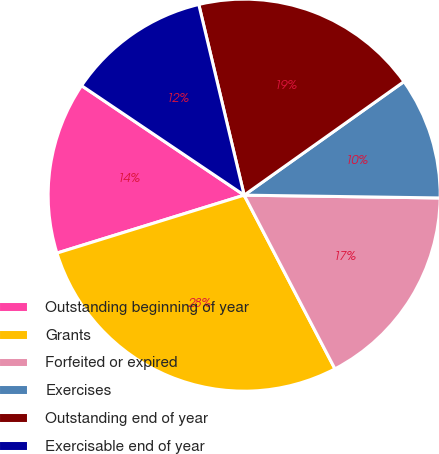Convert chart. <chart><loc_0><loc_0><loc_500><loc_500><pie_chart><fcel>Outstanding beginning of year<fcel>Grants<fcel>Forfeited or expired<fcel>Exercises<fcel>Outstanding end of year<fcel>Exercisable end of year<nl><fcel>14.21%<fcel>27.89%<fcel>17.11%<fcel>10.06%<fcel>18.89%<fcel>11.85%<nl></chart> 